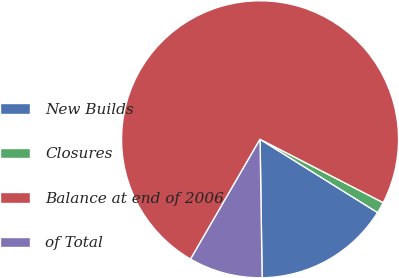Convert chart to OTSL. <chart><loc_0><loc_0><loc_500><loc_500><pie_chart><fcel>New Builds<fcel>Closures<fcel>Balance at end of 2006<fcel>of Total<nl><fcel>15.89%<fcel>1.31%<fcel>74.21%<fcel>8.6%<nl></chart> 